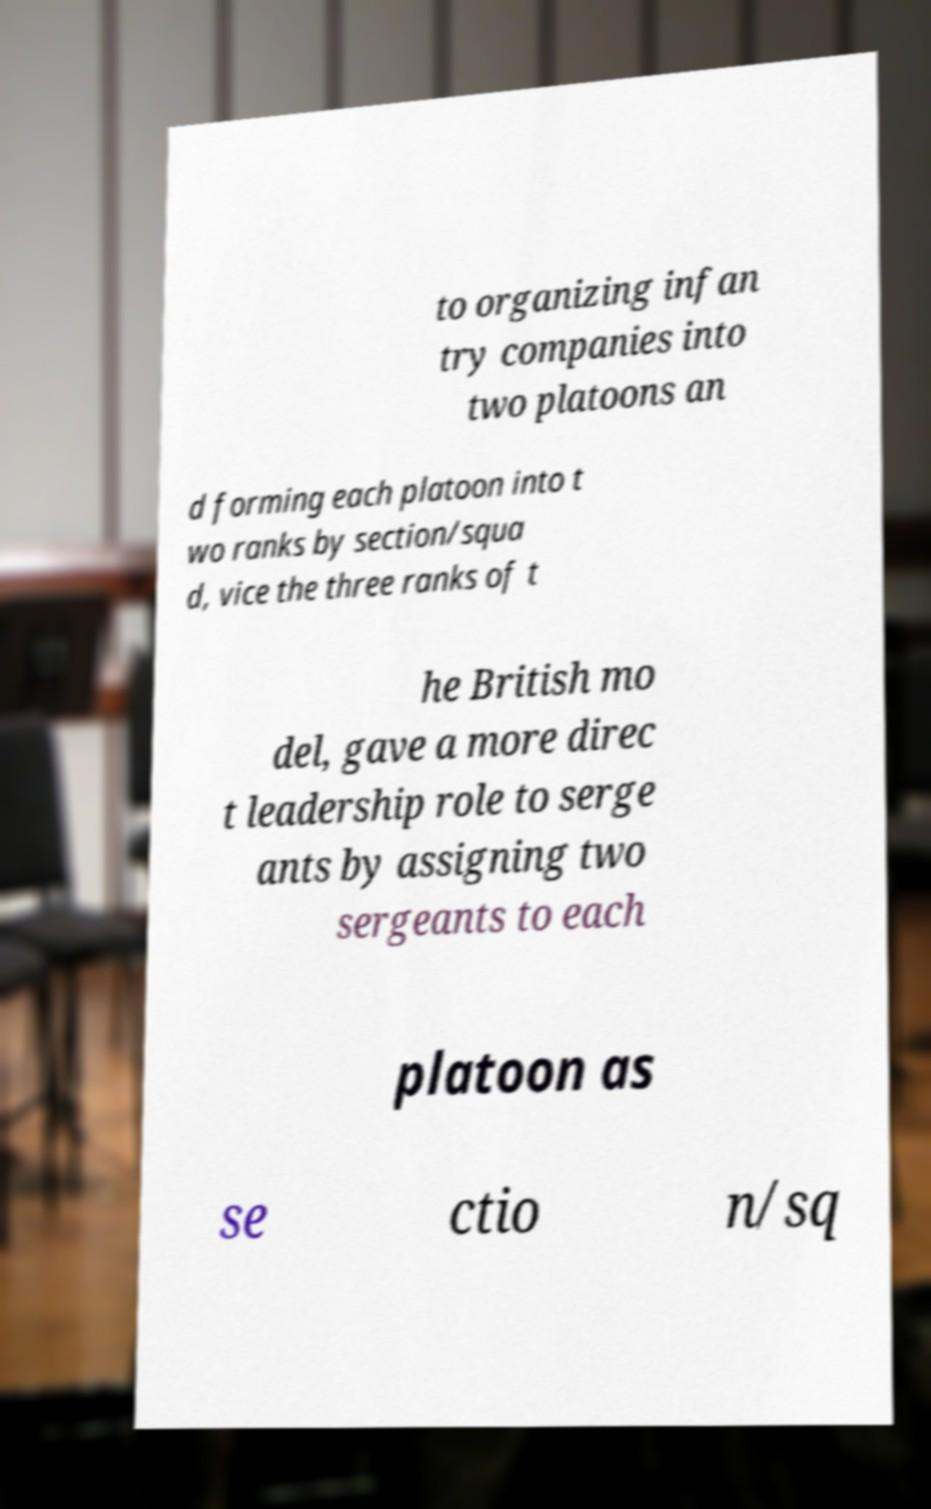There's text embedded in this image that I need extracted. Can you transcribe it verbatim? to organizing infan try companies into two platoons an d forming each platoon into t wo ranks by section/squa d, vice the three ranks of t he British mo del, gave a more direc t leadership role to serge ants by assigning two sergeants to each platoon as se ctio n/sq 